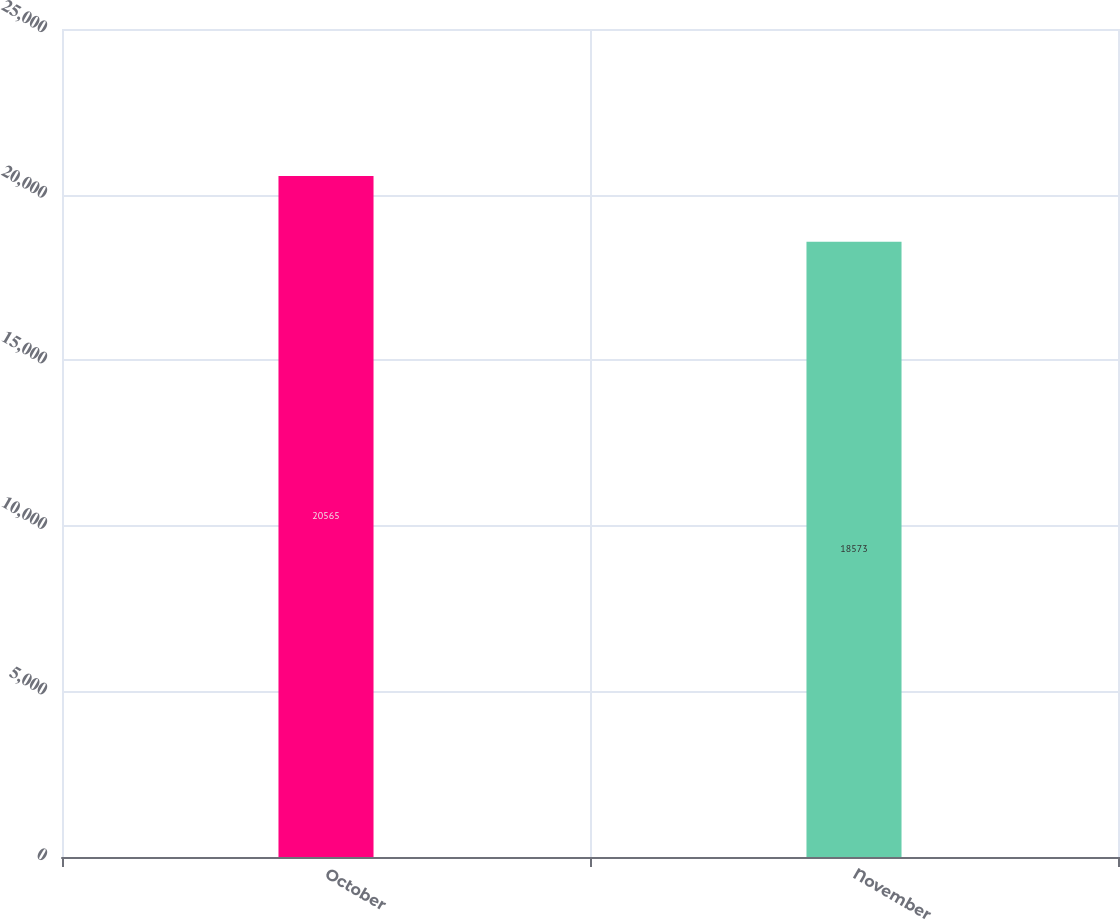Convert chart to OTSL. <chart><loc_0><loc_0><loc_500><loc_500><bar_chart><fcel>October<fcel>November<nl><fcel>20565<fcel>18573<nl></chart> 